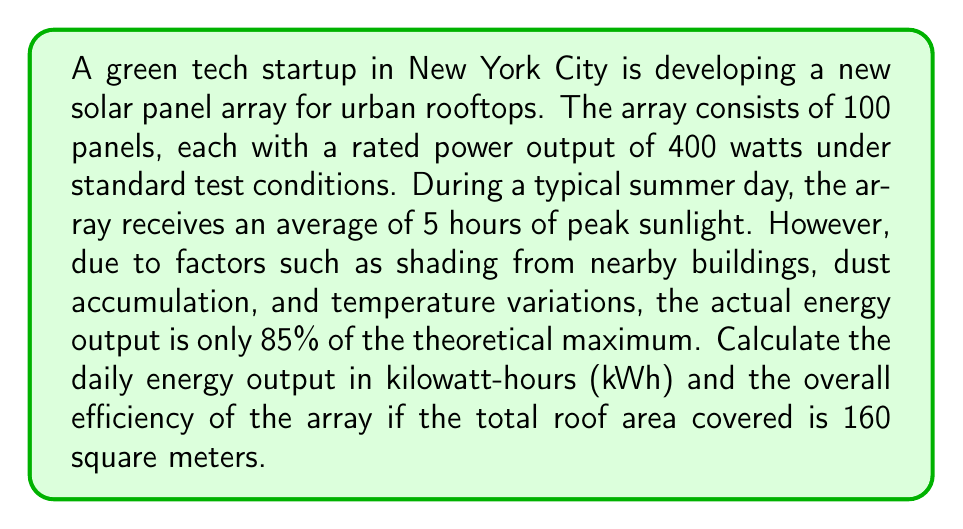Show me your answer to this math problem. Let's break this down step-by-step:

1. Calculate the theoretical maximum power output:
   $$ P_{max} = 100 \text{ panels} \times 400 \text{ watts} = 40,000 \text{ watts} = 40 \text{ kW} $$

2. Calculate the theoretical maximum daily energy output:
   $$ E_{max} = 40 \text{ kW} \times 5 \text{ hours} = 200 \text{ kWh} $$

3. Calculate the actual daily energy output (85% of theoretical):
   $$ E_{actual} = 200 \text{ kWh} \times 0.85 = 170 \text{ kWh} $$

4. Calculate the actual power output:
   $$ P_{actual} = \frac{E_{actual}}{5 \text{ hours}} = \frac{170 \text{ kWh}}{5 \text{ h}} = 34 \text{ kW} $$

5. Calculate the overall efficiency:
   $$ \text{Efficiency} = \frac{P_{actual}}{\text{Area} \times \text{Solar Irradiance}} $$
   
   Standard solar irradiance is 1000 W/m²
   
   $$ \text{Efficiency} = \frac{34,000 \text{ W}}{160 \text{ m}^2 \times 1000 \text{ W/m}^2} = 0.2125 = 21.25\% $$
Answer: 170 kWh; 21.25% 